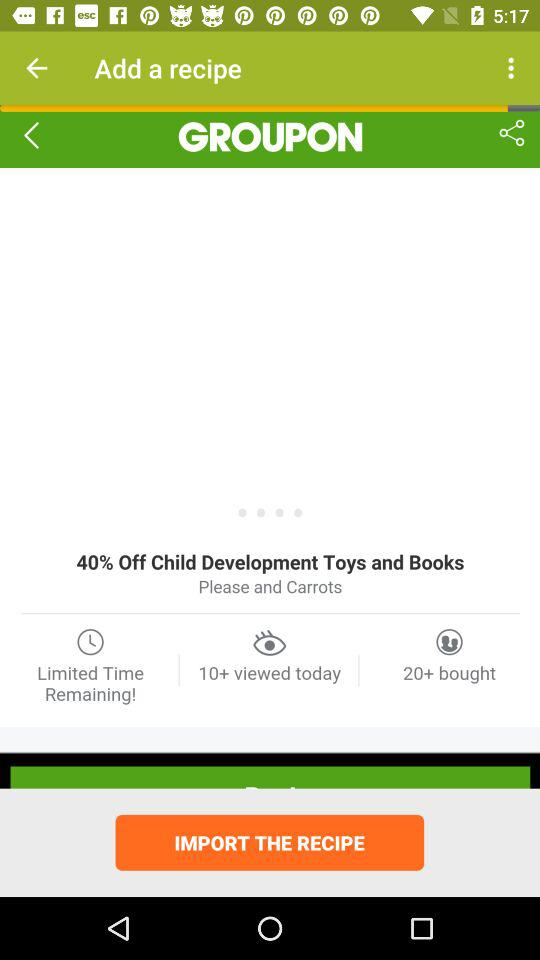How much is off on child development toys and books? There is 40% off on child development toys and books. 